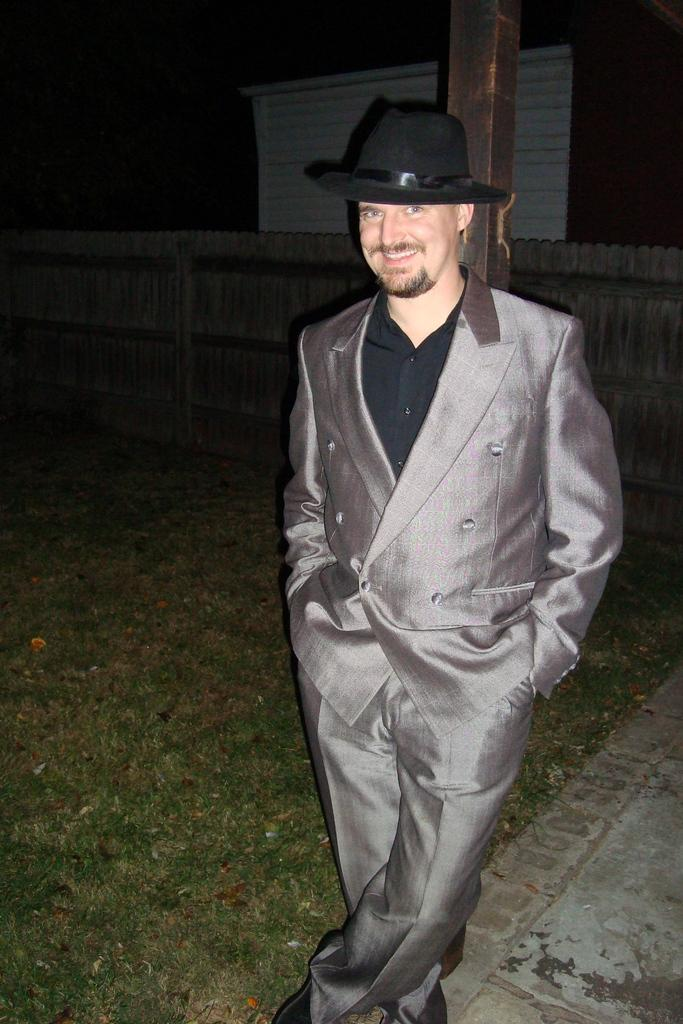What type of vegetation is present in the image? There is grass in the image. Can you describe the person in the image? There is a man in the image, and he is wearing a black hat and a black jacket. What can be seen in the background of the image? There is a wall in the background of the image. What type of rock is the man holding in the image? There is no rock present in the image; the man is not holding anything. 